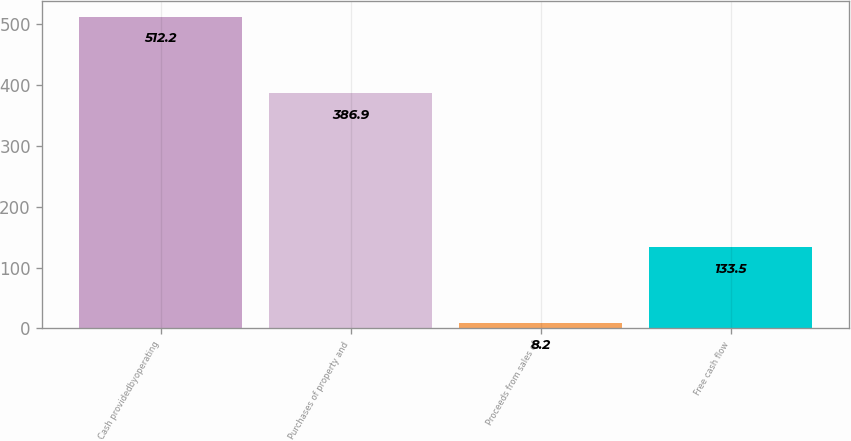Convert chart. <chart><loc_0><loc_0><loc_500><loc_500><bar_chart><fcel>Cash providedbyoperating<fcel>Purchases of property and<fcel>Proceeds from sales of<fcel>Free cash flow<nl><fcel>512.2<fcel>386.9<fcel>8.2<fcel>133.5<nl></chart> 